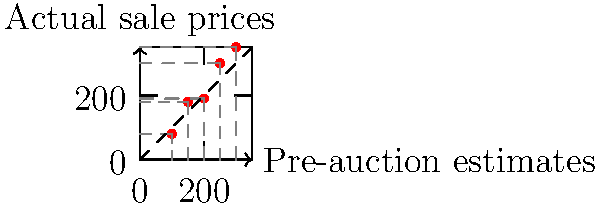In the graph above, each red dot represents an auction item, with its pre-auction estimate on the x-axis and its actual sale price on the y-axis. The dashed line represents where estimates would perfectly match actual prices. Calculate the vector that represents the average discrepancy between pre-auction estimates and actual sale prices. What does this vector reveal about the auction industry's accuracy in pricing? To solve this problem, we'll follow these steps:

1) First, we need to calculate the discrepancy vector for each item:
   $\vec{d_i} = (actual\_price_i - pre\_estimate_i)\hat{j}$

2) For the given data points:
   $\vec{d_1} = (80 - 100)\hat{j} = -20\hat{j}$
   $\vec{d_2} = (180 - 150)\hat{j} = 30\hat{j}$
   $\vec{d_3} = (190 - 200)\hat{j} = -10\hat{j}$
   $\vec{d_4} = (300 - 250)\hat{j} = 50\hat{j}$
   $\vec{d_5} = (350 - 300)\hat{j} = 50\hat{j}$

3) To find the average discrepancy, we sum these vectors and divide by the number of items:

   $\vec{d_{avg}} = \frac{1}{5}(-20\hat{j} + 30\hat{j} - 10\hat{j} + 50\hat{j} + 50\hat{j})$
   
   $\vec{d_{avg}} = \frac{1}{5}(100\hat{j}) = 20\hat{j}$

4) This vector reveals that, on average, actual sale prices are $20 higher than pre-auction estimates.

5) This positive discrepancy suggests that the auction industry tends to underestimate prices slightly, which could be seen as a tactic to attract more bidders or create the illusion of items selling above expectations.
Answer: $20\hat{j}$, indicating systematic underestimation of prices 